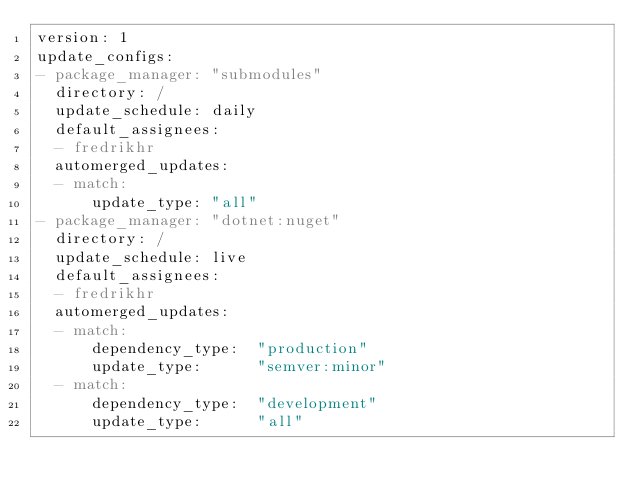Convert code to text. <code><loc_0><loc_0><loc_500><loc_500><_YAML_>version: 1
update_configs:
- package_manager: "submodules"
  directory: /
  update_schedule: daily
  default_assignees:
  - fredrikhr
  automerged_updates:
  - match:
      update_type: "all"
- package_manager: "dotnet:nuget"
  directory: /
  update_schedule: live
  default_assignees:
  - fredrikhr
  automerged_updates:
  - match:
      dependency_type:  "production"
      update_type:      "semver:minor"
  - match:
      dependency_type:  "development"
      update_type:      "all"
</code> 